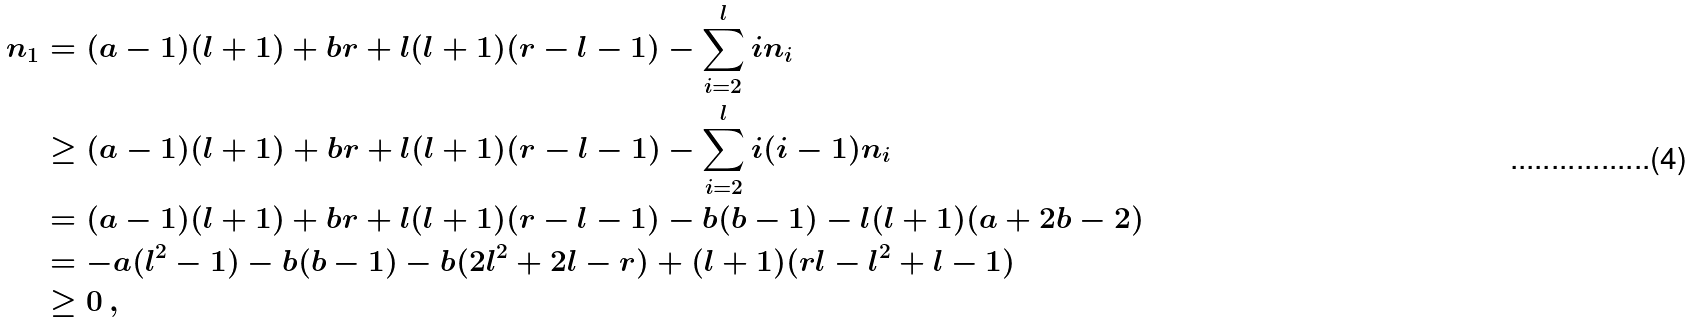<formula> <loc_0><loc_0><loc_500><loc_500>n _ { 1 } & = ( a - 1 ) ( l + 1 ) + b r + l ( l + 1 ) ( r - l - 1 ) - \sum ^ { l } _ { i = 2 } i n _ { i } \\ & \geq ( a - 1 ) ( l + 1 ) + b r + l ( l + 1 ) ( r - l - 1 ) - \sum ^ { l } _ { i = 2 } i ( i - 1 ) n _ { i } \\ & = ( a - 1 ) ( l + 1 ) + b r + l ( l + 1 ) ( r - l - 1 ) - b ( b - 1 ) - l ( l + 1 ) ( a + 2 b - 2 ) \\ & = - a ( l ^ { 2 } - 1 ) - b ( b - 1 ) - b ( 2 l ^ { 2 } + 2 l - r ) + ( l + 1 ) ( r l - l ^ { 2 } + l - 1 ) \\ & \geq 0 \, ,</formula> 